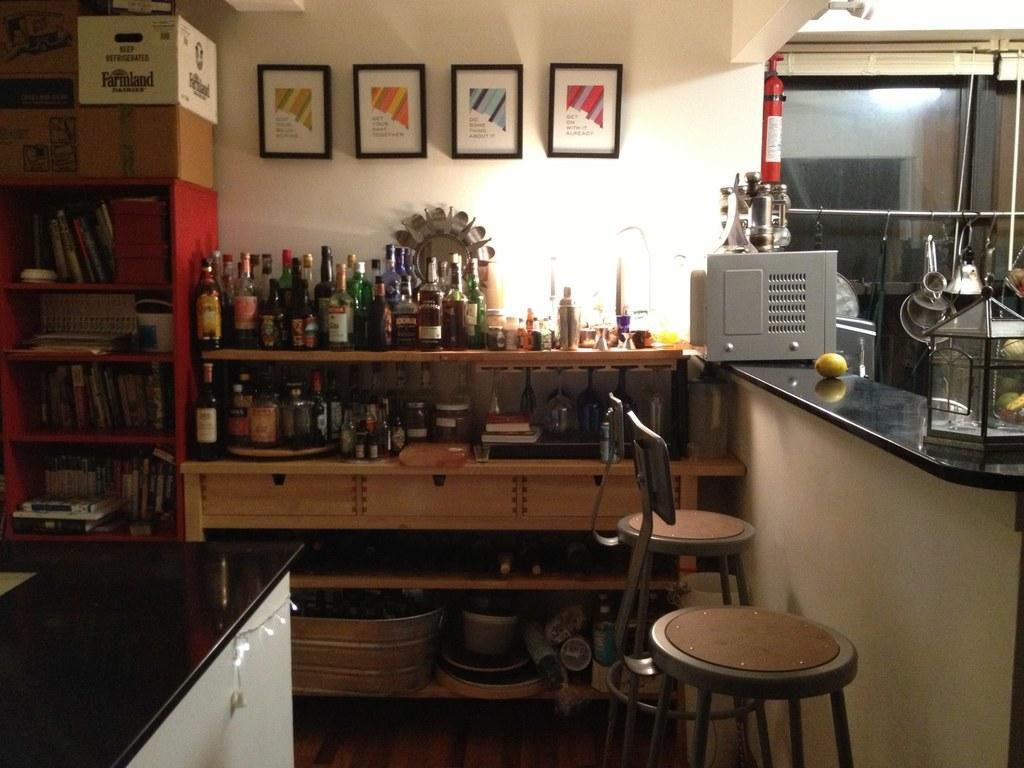How would you summarize this image in a sentence or two? This picture is inside view of a room. We can see a bottles, frame, wall, boxes, books, table, chair, container, vessels, fruit, extinguisher, window, floor, roof are present. 